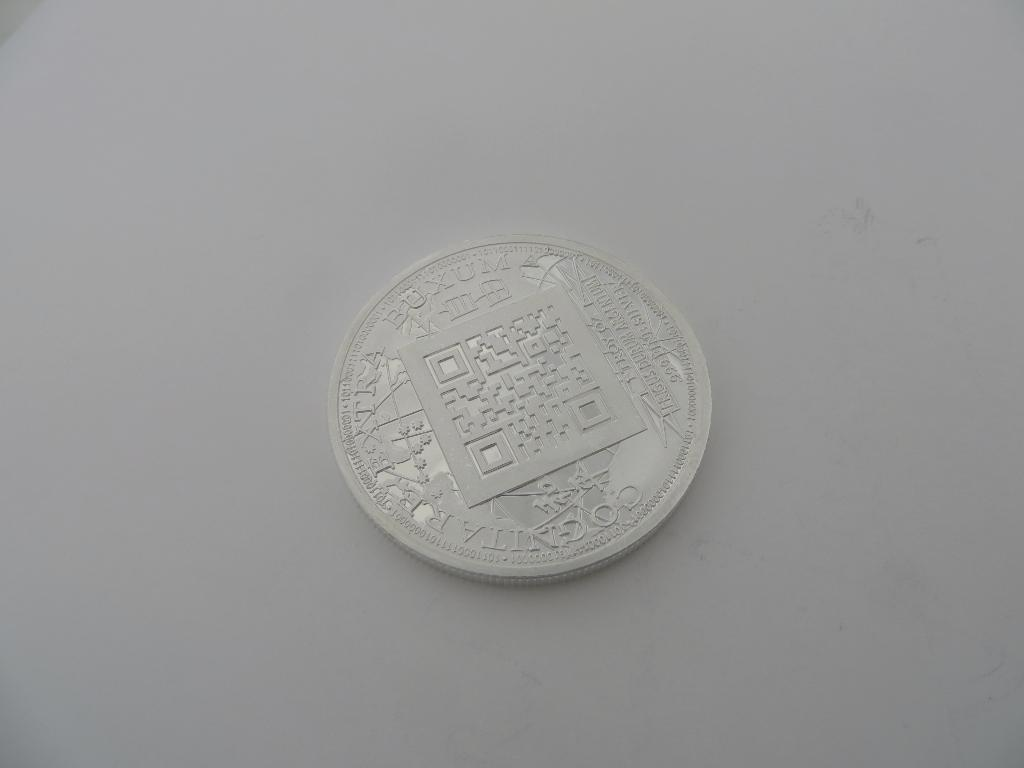<image>
Describe the image concisely. A coin that is made of .999 fine silver. 